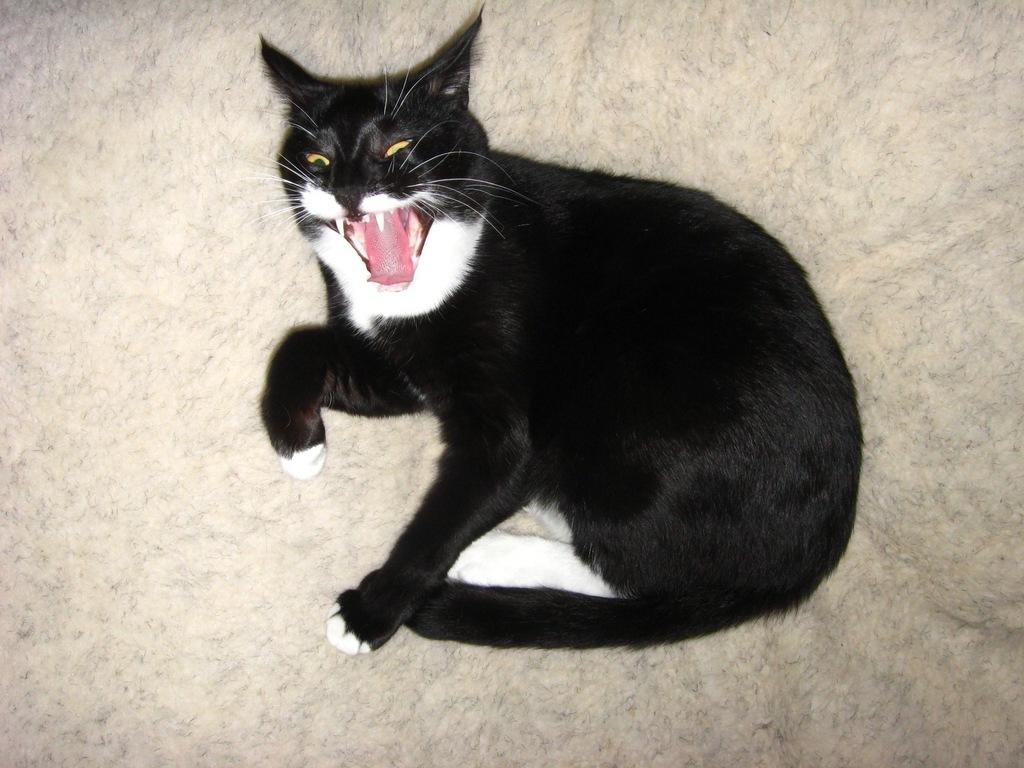What type of animal is in the image? There is a black cat in the image. What is the cat doing or where is it located in the image? The cat is on a surface in the image. What type of tool is the carpenter using in the image? There is no carpenter or tool present in the image; it only features a black cat on a surface. 